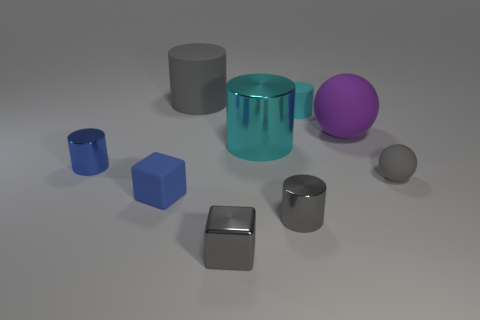What shape is the tiny blue object that is to the left of the blue thing that is right of the cylinder to the left of the rubber block?
Your response must be concise. Cylinder. There is a tiny cyan rubber object; what shape is it?
Provide a short and direct response. Cylinder. There is a gray metallic thing that is the same size as the gray block; what shape is it?
Provide a short and direct response. Cylinder. What number of other objects are the same color as the large matte cylinder?
Ensure brevity in your answer.  3. Does the gray thing that is behind the tiny cyan rubber cylinder have the same shape as the blue object that is to the left of the blue matte object?
Keep it short and to the point. Yes. How many things are big rubber things that are behind the small blue cube or gray rubber balls in front of the large sphere?
Give a very brief answer. 3. How many other objects are the same material as the large ball?
Offer a terse response. 4. Do the gray cylinder on the right side of the large gray rubber cylinder and the large gray thing have the same material?
Provide a short and direct response. No. Is the number of small gray metallic objects that are on the left side of the gray block greater than the number of small gray rubber objects on the left side of the large ball?
Offer a very short reply. No. How many objects are either gray cylinders that are right of the large matte cylinder or tiny blue metallic cylinders?
Provide a succinct answer. 2. 